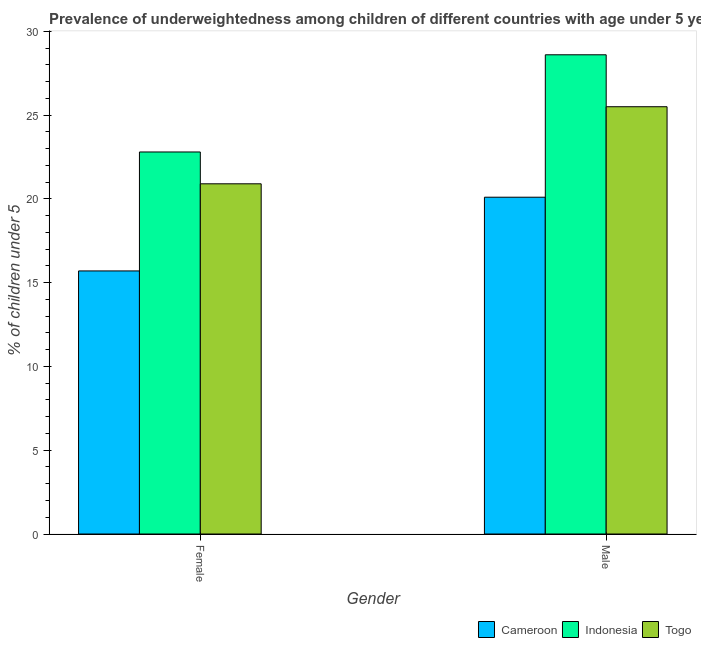How many different coloured bars are there?
Your answer should be very brief. 3. How many groups of bars are there?
Your response must be concise. 2. Are the number of bars per tick equal to the number of legend labels?
Your answer should be compact. Yes. Are the number of bars on each tick of the X-axis equal?
Offer a very short reply. Yes. How many bars are there on the 1st tick from the left?
Ensure brevity in your answer.  3. What is the percentage of underweighted male children in Cameroon?
Your answer should be very brief. 20.1. Across all countries, what is the maximum percentage of underweighted female children?
Ensure brevity in your answer.  22.8. Across all countries, what is the minimum percentage of underweighted male children?
Give a very brief answer. 20.1. In which country was the percentage of underweighted male children maximum?
Provide a succinct answer. Indonesia. In which country was the percentage of underweighted male children minimum?
Offer a very short reply. Cameroon. What is the total percentage of underweighted female children in the graph?
Provide a short and direct response. 59.4. What is the difference between the percentage of underweighted male children in Togo and that in Cameroon?
Ensure brevity in your answer.  5.4. What is the difference between the percentage of underweighted male children in Cameroon and the percentage of underweighted female children in Indonesia?
Offer a terse response. -2.7. What is the average percentage of underweighted male children per country?
Your answer should be very brief. 24.73. What is the difference between the percentage of underweighted female children and percentage of underweighted male children in Cameroon?
Your answer should be very brief. -4.4. What is the ratio of the percentage of underweighted male children in Togo to that in Indonesia?
Provide a short and direct response. 0.89. Is the percentage of underweighted female children in Togo less than that in Cameroon?
Ensure brevity in your answer.  No. In how many countries, is the percentage of underweighted female children greater than the average percentage of underweighted female children taken over all countries?
Keep it short and to the point. 2. What does the 1st bar from the left in Male represents?
Your response must be concise. Cameroon. What does the 2nd bar from the right in Male represents?
Make the answer very short. Indonesia. How many bars are there?
Your answer should be compact. 6. Are all the bars in the graph horizontal?
Make the answer very short. No. What is the difference between two consecutive major ticks on the Y-axis?
Keep it short and to the point. 5. Does the graph contain grids?
Ensure brevity in your answer.  No. How many legend labels are there?
Make the answer very short. 3. How are the legend labels stacked?
Your answer should be very brief. Horizontal. What is the title of the graph?
Offer a very short reply. Prevalence of underweightedness among children of different countries with age under 5 years. Does "Nigeria" appear as one of the legend labels in the graph?
Keep it short and to the point. No. What is the label or title of the Y-axis?
Offer a terse response.  % of children under 5. What is the  % of children under 5 in Cameroon in Female?
Provide a short and direct response. 15.7. What is the  % of children under 5 of Indonesia in Female?
Offer a terse response. 22.8. What is the  % of children under 5 in Togo in Female?
Your answer should be very brief. 20.9. What is the  % of children under 5 of Cameroon in Male?
Keep it short and to the point. 20.1. What is the  % of children under 5 of Indonesia in Male?
Your answer should be very brief. 28.6. What is the  % of children under 5 of Togo in Male?
Provide a succinct answer. 25.5. Across all Gender, what is the maximum  % of children under 5 of Cameroon?
Offer a very short reply. 20.1. Across all Gender, what is the maximum  % of children under 5 in Indonesia?
Make the answer very short. 28.6. Across all Gender, what is the maximum  % of children under 5 of Togo?
Make the answer very short. 25.5. Across all Gender, what is the minimum  % of children under 5 of Cameroon?
Make the answer very short. 15.7. Across all Gender, what is the minimum  % of children under 5 in Indonesia?
Give a very brief answer. 22.8. Across all Gender, what is the minimum  % of children under 5 of Togo?
Your answer should be very brief. 20.9. What is the total  % of children under 5 in Cameroon in the graph?
Provide a short and direct response. 35.8. What is the total  % of children under 5 of Indonesia in the graph?
Provide a succinct answer. 51.4. What is the total  % of children under 5 in Togo in the graph?
Offer a terse response. 46.4. What is the difference between the  % of children under 5 of Cameroon in Female and that in Male?
Ensure brevity in your answer.  -4.4. What is the difference between the  % of children under 5 of Cameroon in Female and the  % of children under 5 of Indonesia in Male?
Keep it short and to the point. -12.9. What is the difference between the  % of children under 5 of Indonesia in Female and the  % of children under 5 of Togo in Male?
Offer a very short reply. -2.7. What is the average  % of children under 5 in Indonesia per Gender?
Keep it short and to the point. 25.7. What is the average  % of children under 5 in Togo per Gender?
Keep it short and to the point. 23.2. What is the difference between the  % of children under 5 of Cameroon and  % of children under 5 of Togo in Female?
Make the answer very short. -5.2. What is the difference between the  % of children under 5 in Indonesia and  % of children under 5 in Togo in Male?
Make the answer very short. 3.1. What is the ratio of the  % of children under 5 of Cameroon in Female to that in Male?
Your response must be concise. 0.78. What is the ratio of the  % of children under 5 in Indonesia in Female to that in Male?
Provide a short and direct response. 0.8. What is the ratio of the  % of children under 5 in Togo in Female to that in Male?
Your response must be concise. 0.82. What is the difference between the highest and the second highest  % of children under 5 of Indonesia?
Make the answer very short. 5.8. What is the difference between the highest and the second highest  % of children under 5 of Togo?
Keep it short and to the point. 4.6. What is the difference between the highest and the lowest  % of children under 5 of Cameroon?
Provide a succinct answer. 4.4. What is the difference between the highest and the lowest  % of children under 5 of Indonesia?
Make the answer very short. 5.8. 